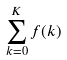Convert formula to latex. <formula><loc_0><loc_0><loc_500><loc_500>\sum _ { k = 0 } ^ { K } f ( k )</formula> 